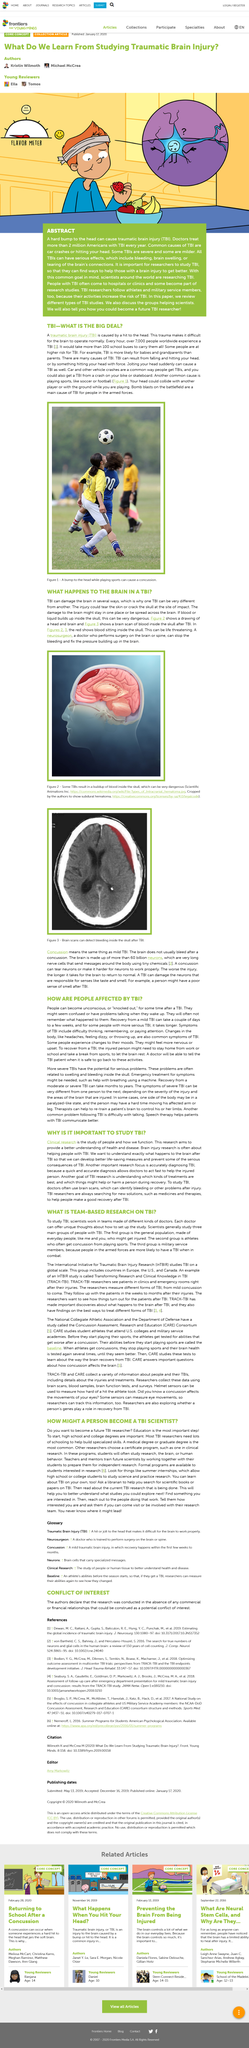Mention a couple of crucial points in this snapshot. Yes, a bump to the head can cause concussion. Traumatic Brain Injury is caused by a direct blow to the head, resulting in damage to the brain. Every hour, approximately 7,000 people worldwide experience traumatic head injuries, resulting in significant health consequences and economic burden. It is a fact that traumatic brain injuries (TBIs) can result in a buildup of blood inside the skull, which can be extremely dangerous. Traumatic brain injury can cause a range of mental symptoms, including difficulty thinking, remembering, or paying attention. 